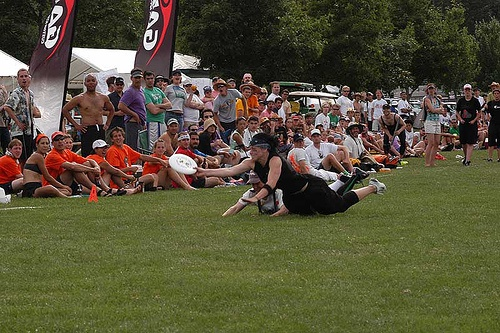Describe the objects in this image and their specific colors. I can see people in black, gray, maroon, and darkgray tones, people in black, gray, and darkgray tones, people in black, maroon, and brown tones, people in black, gray, darkgray, and maroon tones, and people in black, maroon, and brown tones in this image. 